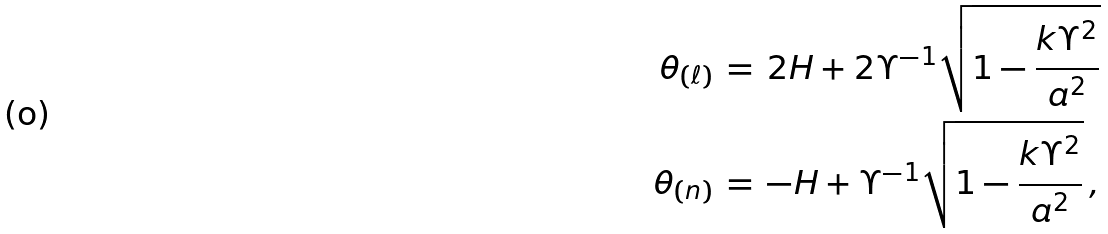Convert formula to latex. <formula><loc_0><loc_0><loc_500><loc_500>\theta _ { ( \ell ) } \, & = \, 2 H + 2 \Upsilon ^ { - 1 } \sqrt { 1 - \frac { k \Upsilon ^ { 2 } } { a ^ { 2 } } } \\ \theta _ { ( n ) } \, & = \, - H + \Upsilon ^ { - 1 } \sqrt { 1 - \frac { k \Upsilon ^ { 2 } } { a ^ { 2 } } } \, ,</formula> 